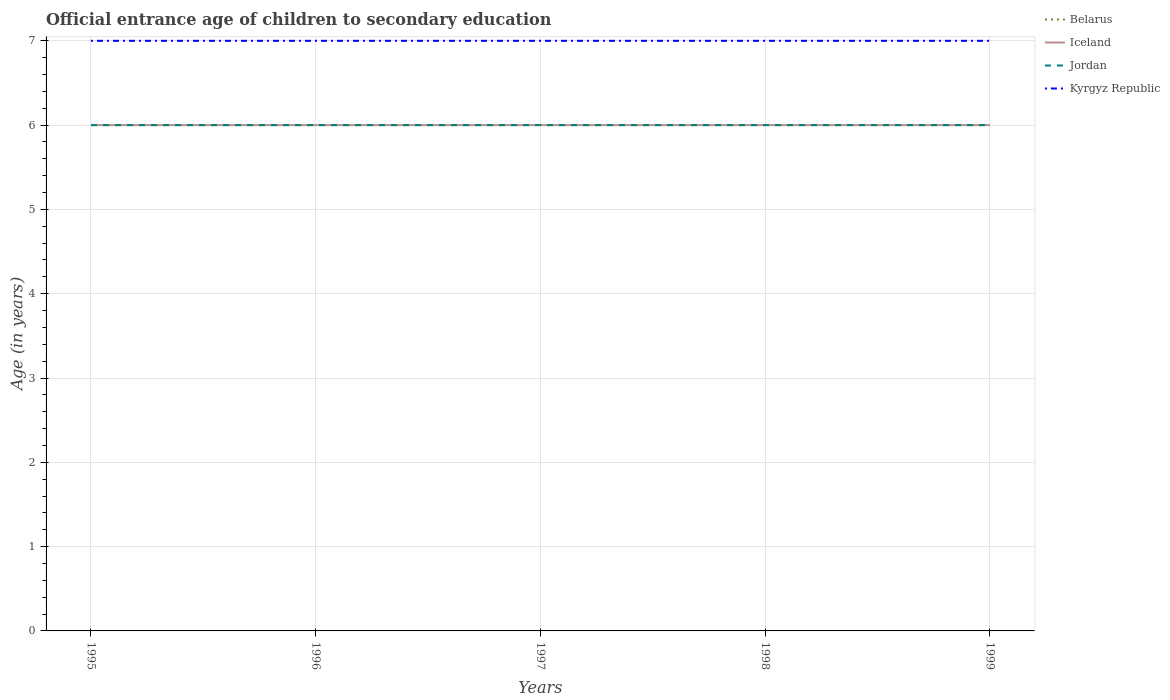Across all years, what is the maximum secondary school starting age of children in Jordan?
Give a very brief answer. 6. What is the total secondary school starting age of children in Belarus in the graph?
Your response must be concise. 0. What is the difference between the highest and the second highest secondary school starting age of children in Iceland?
Offer a terse response. 0. What is the difference between the highest and the lowest secondary school starting age of children in Kyrgyz Republic?
Your answer should be very brief. 0. Is the secondary school starting age of children in Kyrgyz Republic strictly greater than the secondary school starting age of children in Belarus over the years?
Offer a very short reply. No. How many lines are there?
Offer a terse response. 4. What is the difference between two consecutive major ticks on the Y-axis?
Offer a terse response. 1. Where does the legend appear in the graph?
Ensure brevity in your answer.  Top right. How many legend labels are there?
Make the answer very short. 4. What is the title of the graph?
Provide a succinct answer. Official entrance age of children to secondary education. What is the label or title of the Y-axis?
Keep it short and to the point. Age (in years). What is the Age (in years) in Belarus in 1995?
Provide a succinct answer. 6. What is the Age (in years) of Iceland in 1995?
Your answer should be very brief. 6. What is the Age (in years) in Kyrgyz Republic in 1995?
Ensure brevity in your answer.  7. What is the Age (in years) of Belarus in 1996?
Give a very brief answer. 6. What is the Age (in years) in Jordan in 1997?
Offer a very short reply. 6. What is the Age (in years) of Belarus in 1998?
Your answer should be compact. 6. What is the Age (in years) of Iceland in 1998?
Give a very brief answer. 6. What is the Age (in years) of Jordan in 1998?
Provide a succinct answer. 6. What is the Age (in years) in Jordan in 1999?
Your response must be concise. 6. What is the Age (in years) in Kyrgyz Republic in 1999?
Keep it short and to the point. 7. Across all years, what is the maximum Age (in years) in Belarus?
Give a very brief answer. 6. Across all years, what is the minimum Age (in years) in Belarus?
Give a very brief answer. 6. Across all years, what is the minimum Age (in years) in Jordan?
Provide a short and direct response. 6. What is the total Age (in years) in Jordan in the graph?
Make the answer very short. 30. What is the total Age (in years) in Kyrgyz Republic in the graph?
Offer a very short reply. 35. What is the difference between the Age (in years) in Belarus in 1995 and that in 1996?
Provide a succinct answer. 0. What is the difference between the Age (in years) of Kyrgyz Republic in 1995 and that in 1996?
Your answer should be very brief. 0. What is the difference between the Age (in years) of Jordan in 1995 and that in 1997?
Your answer should be compact. 0. What is the difference between the Age (in years) in Kyrgyz Republic in 1995 and that in 1997?
Your response must be concise. 0. What is the difference between the Age (in years) in Belarus in 1995 and that in 1998?
Your answer should be very brief. 0. What is the difference between the Age (in years) of Jordan in 1995 and that in 1998?
Offer a terse response. 0. What is the difference between the Age (in years) of Belarus in 1995 and that in 1999?
Make the answer very short. 0. What is the difference between the Age (in years) of Jordan in 1995 and that in 1999?
Ensure brevity in your answer.  0. What is the difference between the Age (in years) in Kyrgyz Republic in 1995 and that in 1999?
Provide a succinct answer. 0. What is the difference between the Age (in years) of Iceland in 1996 and that in 1997?
Provide a short and direct response. 0. What is the difference between the Age (in years) of Belarus in 1996 and that in 1998?
Ensure brevity in your answer.  0. What is the difference between the Age (in years) in Iceland in 1996 and that in 1998?
Give a very brief answer. 0. What is the difference between the Age (in years) of Jordan in 1996 and that in 1998?
Keep it short and to the point. 0. What is the difference between the Age (in years) of Belarus in 1996 and that in 1999?
Ensure brevity in your answer.  0. What is the difference between the Age (in years) of Jordan in 1996 and that in 1999?
Ensure brevity in your answer.  0. What is the difference between the Age (in years) of Kyrgyz Republic in 1996 and that in 1999?
Give a very brief answer. 0. What is the difference between the Age (in years) of Belarus in 1997 and that in 1998?
Your answer should be compact. 0. What is the difference between the Age (in years) of Jordan in 1997 and that in 1998?
Make the answer very short. 0. What is the difference between the Age (in years) of Belarus in 1997 and that in 1999?
Provide a short and direct response. 0. What is the difference between the Age (in years) in Jordan in 1997 and that in 1999?
Give a very brief answer. 0. What is the difference between the Age (in years) of Kyrgyz Republic in 1997 and that in 1999?
Your response must be concise. 0. What is the difference between the Age (in years) in Belarus in 1998 and that in 1999?
Offer a terse response. 0. What is the difference between the Age (in years) in Iceland in 1998 and that in 1999?
Offer a very short reply. 0. What is the difference between the Age (in years) of Kyrgyz Republic in 1998 and that in 1999?
Give a very brief answer. 0. What is the difference between the Age (in years) in Belarus in 1995 and the Age (in years) in Iceland in 1996?
Provide a short and direct response. 0. What is the difference between the Age (in years) of Belarus in 1995 and the Age (in years) of Kyrgyz Republic in 1996?
Your answer should be very brief. -1. What is the difference between the Age (in years) of Belarus in 1995 and the Age (in years) of Kyrgyz Republic in 1997?
Ensure brevity in your answer.  -1. What is the difference between the Age (in years) in Iceland in 1995 and the Age (in years) in Kyrgyz Republic in 1997?
Ensure brevity in your answer.  -1. What is the difference between the Age (in years) of Jordan in 1995 and the Age (in years) of Kyrgyz Republic in 1997?
Offer a terse response. -1. What is the difference between the Age (in years) in Belarus in 1995 and the Age (in years) in Jordan in 1998?
Offer a terse response. 0. What is the difference between the Age (in years) of Iceland in 1995 and the Age (in years) of Kyrgyz Republic in 1998?
Ensure brevity in your answer.  -1. What is the difference between the Age (in years) in Iceland in 1995 and the Age (in years) in Jordan in 1999?
Offer a terse response. 0. What is the difference between the Age (in years) in Jordan in 1995 and the Age (in years) in Kyrgyz Republic in 1999?
Give a very brief answer. -1. What is the difference between the Age (in years) of Belarus in 1996 and the Age (in years) of Jordan in 1997?
Offer a very short reply. 0. What is the difference between the Age (in years) of Iceland in 1996 and the Age (in years) of Jordan in 1997?
Offer a very short reply. 0. What is the difference between the Age (in years) of Belarus in 1996 and the Age (in years) of Iceland in 1998?
Provide a succinct answer. 0. What is the difference between the Age (in years) in Belarus in 1996 and the Age (in years) in Jordan in 1998?
Offer a terse response. 0. What is the difference between the Age (in years) of Belarus in 1996 and the Age (in years) of Kyrgyz Republic in 1998?
Make the answer very short. -1. What is the difference between the Age (in years) of Belarus in 1996 and the Age (in years) of Jordan in 1999?
Your answer should be very brief. 0. What is the difference between the Age (in years) in Iceland in 1996 and the Age (in years) in Jordan in 1999?
Provide a succinct answer. 0. What is the difference between the Age (in years) of Iceland in 1996 and the Age (in years) of Kyrgyz Republic in 1999?
Give a very brief answer. -1. What is the difference between the Age (in years) of Jordan in 1996 and the Age (in years) of Kyrgyz Republic in 1999?
Give a very brief answer. -1. What is the difference between the Age (in years) of Belarus in 1997 and the Age (in years) of Jordan in 1998?
Provide a succinct answer. 0. What is the difference between the Age (in years) in Belarus in 1997 and the Age (in years) in Kyrgyz Republic in 1998?
Offer a terse response. -1. What is the difference between the Age (in years) in Iceland in 1997 and the Age (in years) in Jordan in 1998?
Give a very brief answer. 0. What is the difference between the Age (in years) in Belarus in 1997 and the Age (in years) in Iceland in 1999?
Your answer should be very brief. 0. What is the difference between the Age (in years) in Belarus in 1997 and the Age (in years) in Jordan in 1999?
Your answer should be very brief. 0. What is the difference between the Age (in years) of Belarus in 1997 and the Age (in years) of Kyrgyz Republic in 1999?
Your response must be concise. -1. What is the difference between the Age (in years) in Iceland in 1997 and the Age (in years) in Jordan in 1999?
Your answer should be very brief. 0. What is the difference between the Age (in years) in Belarus in 1998 and the Age (in years) in Iceland in 1999?
Keep it short and to the point. 0. What is the difference between the Age (in years) in Belarus in 1998 and the Age (in years) in Jordan in 1999?
Your answer should be very brief. 0. What is the difference between the Age (in years) in Belarus in 1998 and the Age (in years) in Kyrgyz Republic in 1999?
Give a very brief answer. -1. What is the difference between the Age (in years) of Iceland in 1998 and the Age (in years) of Jordan in 1999?
Keep it short and to the point. 0. What is the average Age (in years) in Belarus per year?
Your answer should be very brief. 6. What is the average Age (in years) of Kyrgyz Republic per year?
Make the answer very short. 7. In the year 1996, what is the difference between the Age (in years) in Belarus and Age (in years) in Jordan?
Your response must be concise. 0. In the year 1996, what is the difference between the Age (in years) of Belarus and Age (in years) of Kyrgyz Republic?
Keep it short and to the point. -1. In the year 1996, what is the difference between the Age (in years) of Iceland and Age (in years) of Jordan?
Provide a succinct answer. 0. In the year 1997, what is the difference between the Age (in years) of Iceland and Age (in years) of Jordan?
Your response must be concise. 0. In the year 1997, what is the difference between the Age (in years) in Iceland and Age (in years) in Kyrgyz Republic?
Give a very brief answer. -1. In the year 1997, what is the difference between the Age (in years) in Jordan and Age (in years) in Kyrgyz Republic?
Your response must be concise. -1. In the year 1998, what is the difference between the Age (in years) of Belarus and Age (in years) of Jordan?
Provide a succinct answer. 0. In the year 1998, what is the difference between the Age (in years) of Belarus and Age (in years) of Kyrgyz Republic?
Offer a very short reply. -1. In the year 1998, what is the difference between the Age (in years) in Iceland and Age (in years) in Jordan?
Offer a very short reply. 0. In the year 1998, what is the difference between the Age (in years) of Iceland and Age (in years) of Kyrgyz Republic?
Your answer should be compact. -1. In the year 1998, what is the difference between the Age (in years) of Jordan and Age (in years) of Kyrgyz Republic?
Provide a succinct answer. -1. In the year 1999, what is the difference between the Age (in years) in Iceland and Age (in years) in Kyrgyz Republic?
Your answer should be very brief. -1. What is the ratio of the Age (in years) of Belarus in 1995 to that in 1996?
Your answer should be very brief. 1. What is the ratio of the Age (in years) in Jordan in 1995 to that in 1996?
Provide a short and direct response. 1. What is the ratio of the Age (in years) in Jordan in 1995 to that in 1997?
Your answer should be very brief. 1. What is the ratio of the Age (in years) of Kyrgyz Republic in 1995 to that in 1997?
Make the answer very short. 1. What is the ratio of the Age (in years) of Belarus in 1995 to that in 1998?
Provide a succinct answer. 1. What is the ratio of the Age (in years) of Iceland in 1995 to that in 1998?
Provide a short and direct response. 1. What is the ratio of the Age (in years) of Kyrgyz Republic in 1995 to that in 1998?
Make the answer very short. 1. What is the ratio of the Age (in years) of Iceland in 1995 to that in 1999?
Your answer should be very brief. 1. What is the ratio of the Age (in years) in Kyrgyz Republic in 1995 to that in 1999?
Your response must be concise. 1. What is the ratio of the Age (in years) of Belarus in 1996 to that in 1997?
Offer a very short reply. 1. What is the ratio of the Age (in years) in Jordan in 1996 to that in 1997?
Offer a terse response. 1. What is the ratio of the Age (in years) of Kyrgyz Republic in 1996 to that in 1997?
Make the answer very short. 1. What is the ratio of the Age (in years) in Belarus in 1996 to that in 1998?
Ensure brevity in your answer.  1. What is the ratio of the Age (in years) in Jordan in 1996 to that in 1998?
Keep it short and to the point. 1. What is the ratio of the Age (in years) of Kyrgyz Republic in 1996 to that in 1998?
Provide a succinct answer. 1. What is the ratio of the Age (in years) of Belarus in 1996 to that in 1999?
Keep it short and to the point. 1. What is the ratio of the Age (in years) of Iceland in 1996 to that in 1999?
Ensure brevity in your answer.  1. What is the ratio of the Age (in years) in Jordan in 1997 to that in 1998?
Your response must be concise. 1. What is the ratio of the Age (in years) in Iceland in 1997 to that in 1999?
Provide a succinct answer. 1. What is the ratio of the Age (in years) in Jordan in 1997 to that in 1999?
Your answer should be compact. 1. What is the difference between the highest and the second highest Age (in years) of Belarus?
Give a very brief answer. 0. What is the difference between the highest and the second highest Age (in years) in Iceland?
Provide a short and direct response. 0. What is the difference between the highest and the lowest Age (in years) of Jordan?
Provide a succinct answer. 0. What is the difference between the highest and the lowest Age (in years) in Kyrgyz Republic?
Your response must be concise. 0. 